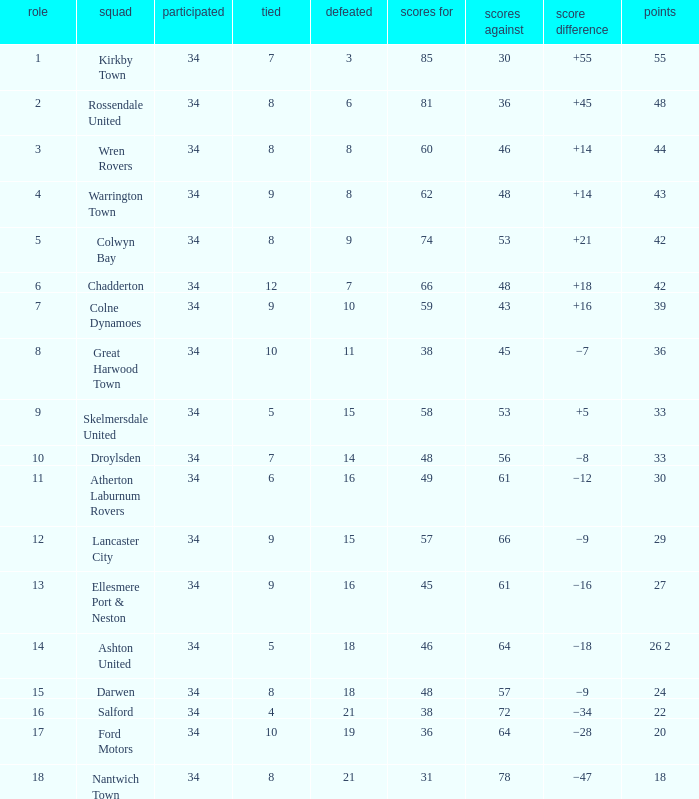How many total positions are there when the goals against exceed 48, one of the 29 points has been played, and fewer than 34 games have taken place? 0.0. 